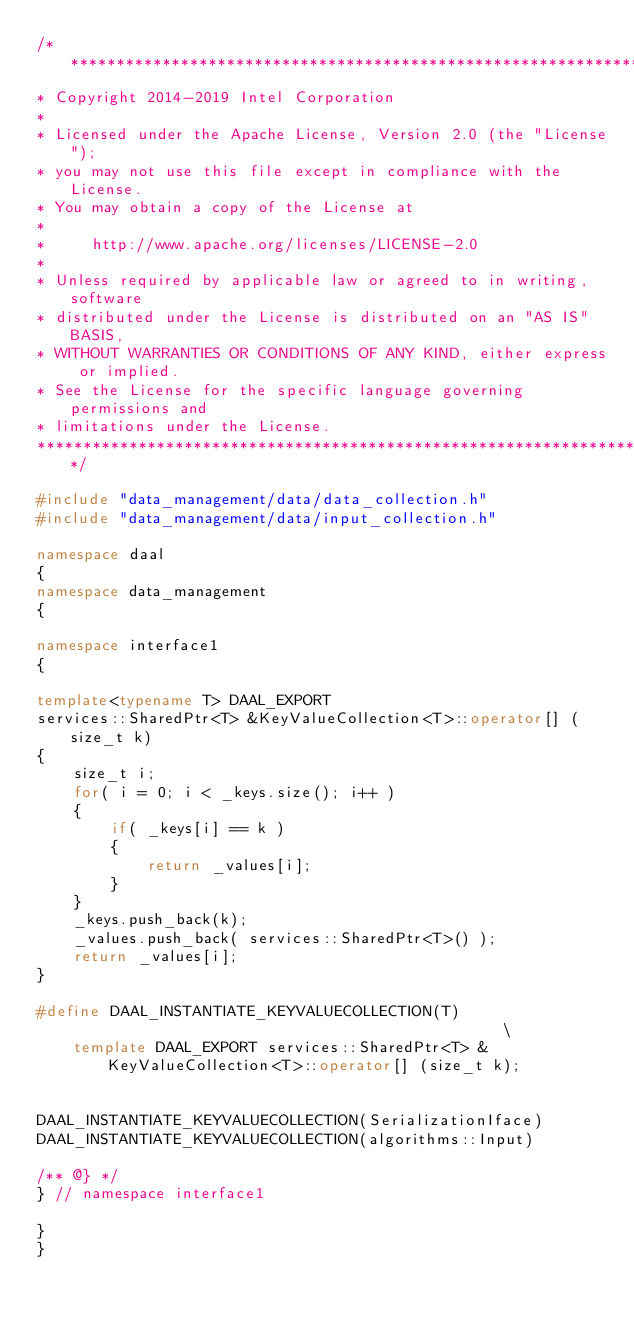<code> <loc_0><loc_0><loc_500><loc_500><_C++_>/*******************************************************************************
* Copyright 2014-2019 Intel Corporation
*
* Licensed under the Apache License, Version 2.0 (the "License");
* you may not use this file except in compliance with the License.
* You may obtain a copy of the License at
*
*     http://www.apache.org/licenses/LICENSE-2.0
*
* Unless required by applicable law or agreed to in writing, software
* distributed under the License is distributed on an "AS IS" BASIS,
* WITHOUT WARRANTIES OR CONDITIONS OF ANY KIND, either express or implied.
* See the License for the specific language governing permissions and
* limitations under the License.
*******************************************************************************/

#include "data_management/data/data_collection.h"
#include "data_management/data/input_collection.h"

namespace daal
{
namespace data_management
{

namespace interface1
{

template<typename T> DAAL_EXPORT
services::SharedPtr<T> &KeyValueCollection<T>::operator[] (size_t k)
{
    size_t i;
    for( i = 0; i < _keys.size(); i++ )
    {
        if( _keys[i] == k )
        {
            return _values[i];
        }
    }
    _keys.push_back(k);
    _values.push_back( services::SharedPtr<T>() );
    return _values[i];
}

#define DAAL_INSTANTIATE_KEYVALUECOLLECTION(T)                                                \
    template DAAL_EXPORT services::SharedPtr<T> & KeyValueCollection<T>::operator[] (size_t k);


DAAL_INSTANTIATE_KEYVALUECOLLECTION(SerializationIface)
DAAL_INSTANTIATE_KEYVALUECOLLECTION(algorithms::Input)

/** @} */
} // namespace interface1

}
}
</code> 